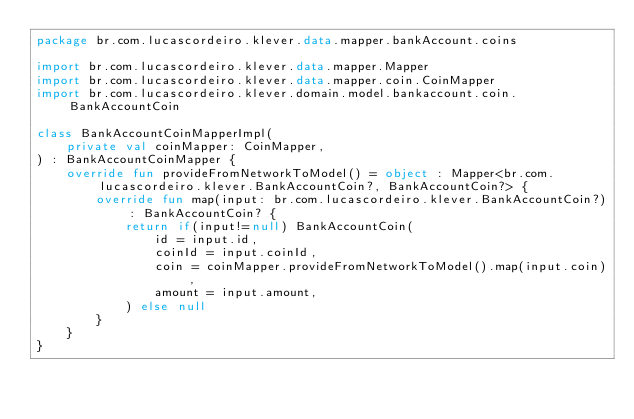<code> <loc_0><loc_0><loc_500><loc_500><_Kotlin_>package br.com.lucascordeiro.klever.data.mapper.bankAccount.coins

import br.com.lucascordeiro.klever.data.mapper.Mapper
import br.com.lucascordeiro.klever.data.mapper.coin.CoinMapper
import br.com.lucascordeiro.klever.domain.model.bankaccount.coin.BankAccountCoin

class BankAccountCoinMapperImpl(
    private val coinMapper: CoinMapper,
) : BankAccountCoinMapper {
    override fun provideFromNetworkToModel() = object : Mapper<br.com.lucascordeiro.klever.BankAccountCoin?, BankAccountCoin?> {
        override fun map(input: br.com.lucascordeiro.klever.BankAccountCoin?): BankAccountCoin? {
            return if(input!=null) BankAccountCoin(
                id = input.id,
                coinId = input.coinId,
                coin = coinMapper.provideFromNetworkToModel().map(input.coin),
                amount = input.amount,
            ) else null
        }
    }
}</code> 